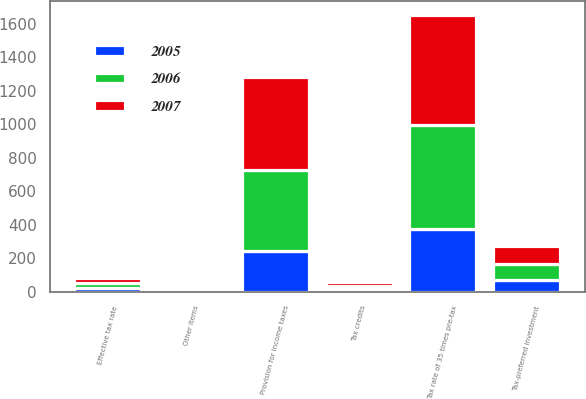Convert chart. <chart><loc_0><loc_0><loc_500><loc_500><stacked_bar_chart><ecel><fcel>Tax rate of 35 times pre-tax<fcel>Tax-preferred investment<fcel>Tax credits<fcel>Other items<fcel>Provision for income taxes<fcel>Effective tax rate<nl><fcel>2007<fcel>656<fcel>105<fcel>21<fcel>18<fcel>553<fcel>30<nl><fcel>2006<fcel>622<fcel>98<fcel>23<fcel>18<fcel>483<fcel>27<nl><fcel>2005<fcel>376<fcel>69<fcel>14<fcel>2<fcel>244<fcel>23<nl></chart> 